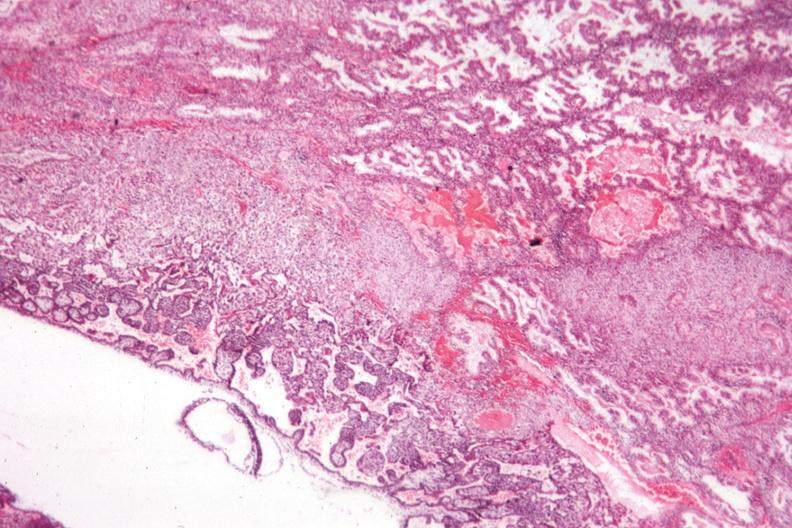s fetus developing very early present?
Answer the question using a single word or phrase. Yes 